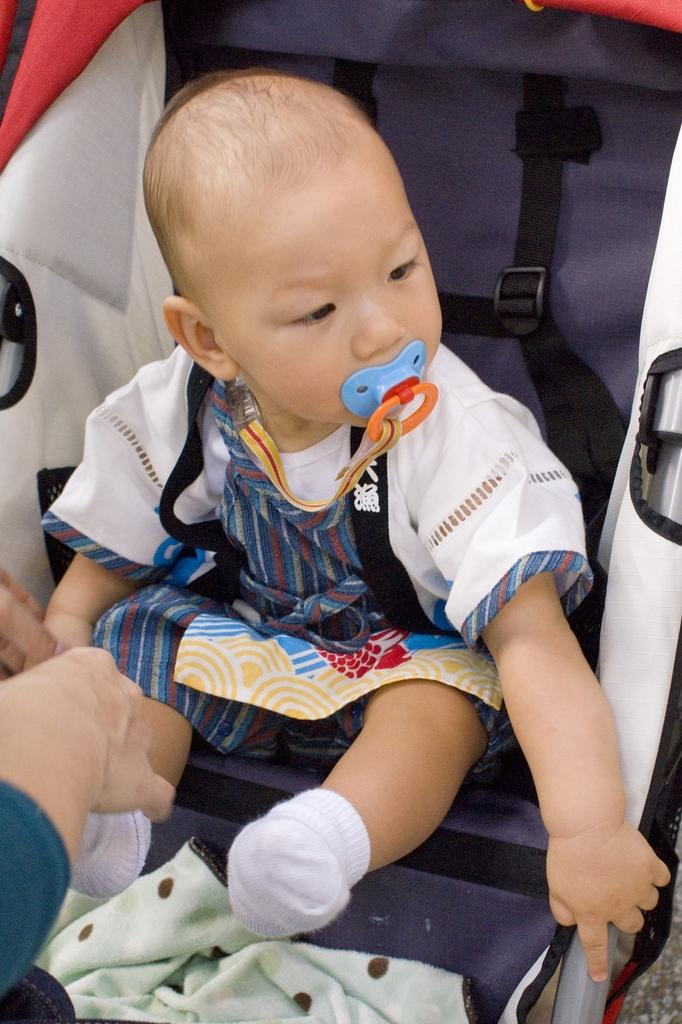What is the main subject of the image? There is a baby in the image. What is the baby wearing? The baby is wearing a white and blue colored dress and white socks. Where is the baby located in the image? The baby is sitting in a stroller. Can you describe any other details in the image? There is a person's hand on the left side of the image. What type of cap is the baby wearing in the image? There is no cap visible in the image; the baby is wearing a white and blue colored dress and white socks. Is the baby participating in a battle in the image? There is no indication of a battle or any conflict in the image; it features a baby sitting in a stroller. 